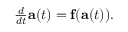<formula> <loc_0><loc_0><loc_500><loc_500>\begin{array} { r } { \frac { d } { d t } a ( t ) = f ( a ( t ) ) . } \end{array}</formula> 